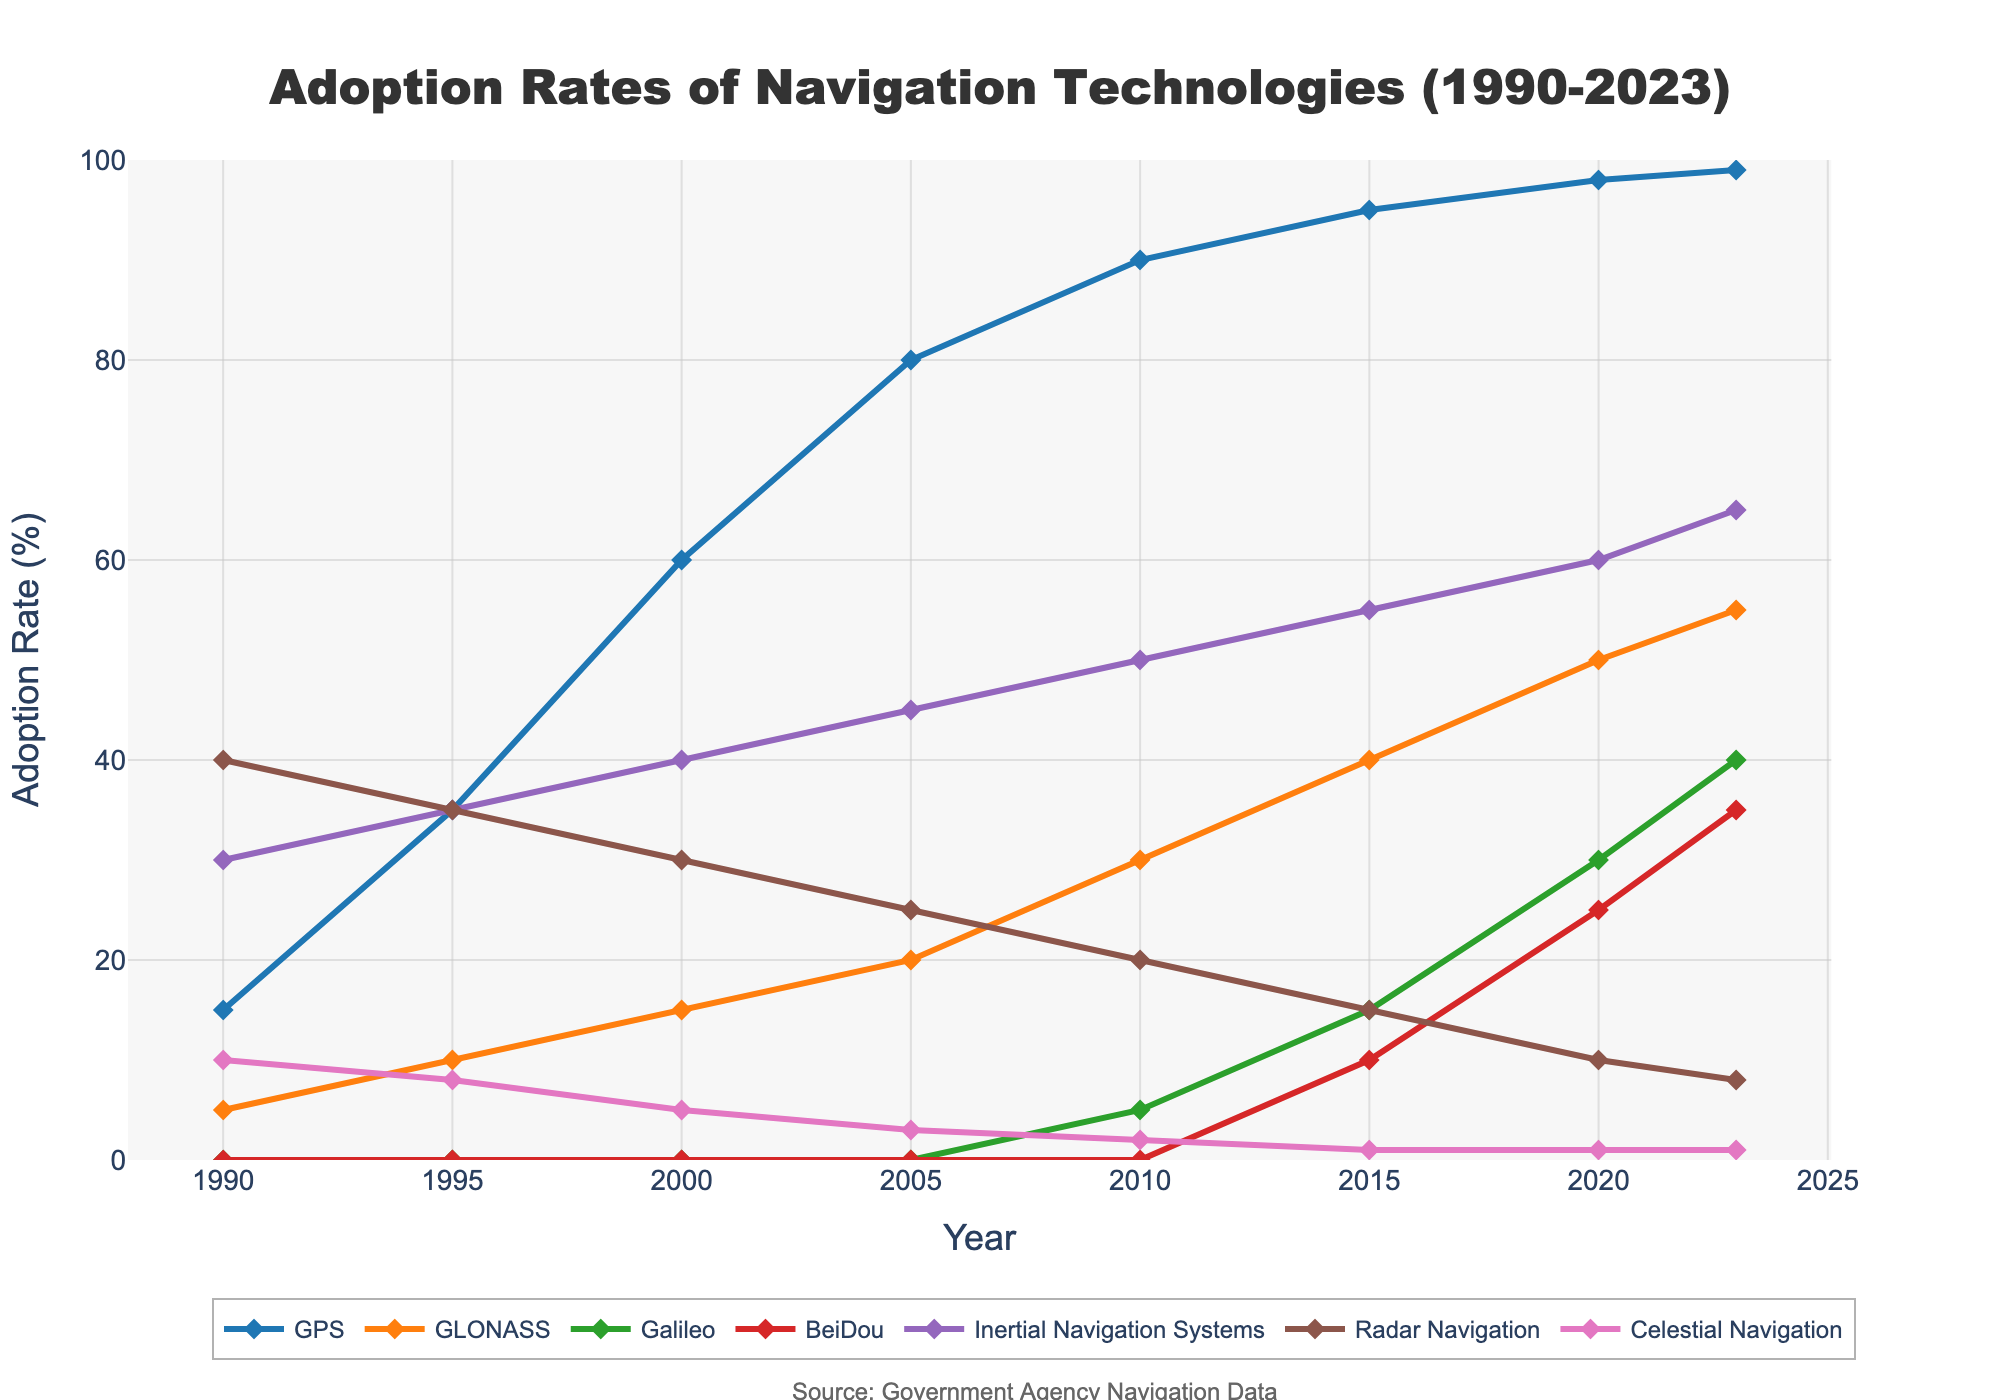what is the adoption rate of GPS in 2023? Refer to the GPS line for the year 2023, which reads 99%.
Answer: 99% How much did the adoption rate of GLONASS increase from 1990 to 2023? Subtract the adoption rate of GLONASS in 1990 (5%) from its rate in 2023 (55%). 55% - 5% = 50%
Answer: 50% Which technology had the highest adoption rate in 2005? Compare the adoption rates in 2005. GPS has the highest adoption at 80%.
Answer: GPS What's the sum of the adoption rates of BeiDou and Galileo in 2023? Add the adoption rates of BeiDou (35%) and Galileo (40%) in 2023. 35% + 40% = 75%
Answer: 75% Which navigation technology has a lower adoption rate in 2023, Radar Navigation or Celestial Navigation? Compare their rates in 2023: Radar Navigation at 8% and Celestial Navigation at 1%. 1% < 8%
Answer: Celestial Navigation What was the average adoption rate of Inertial Navigation Systems between 1990 and 2023? Add all adoption rates for Inertial Navigation Systems over the years and divide by the number of years. (30+35+40+45+50+55+60+65)/8 = 47.5%
Answer: 47.5% By how much did the adoption rate of Galileo change from 2010 to 2023? Subtract the adoption rate in 2010 (5%) from 2023 (40%). 40% - 5% = 35%
Answer: 35% Which technology showed a steady increase every 5 years? By inspecting the line chart, GPS shows a steady increase every 5 years from 1990 to 2023.
Answer: GPS How did the adoption rate of BeiDou in 2020 compare to that in 2010? BeiDou had an adoption rate of 25% in 2020 and 0% in 2010, so it increased by 25%.
Answer: 25% Which technology showed the least change in adoption rates from 1990 to 2023? Celestial Navigation had minimal changes, starting at 10% in 1990 and only adjusting to 1% by 2023.
Answer: Celestial Navigation 